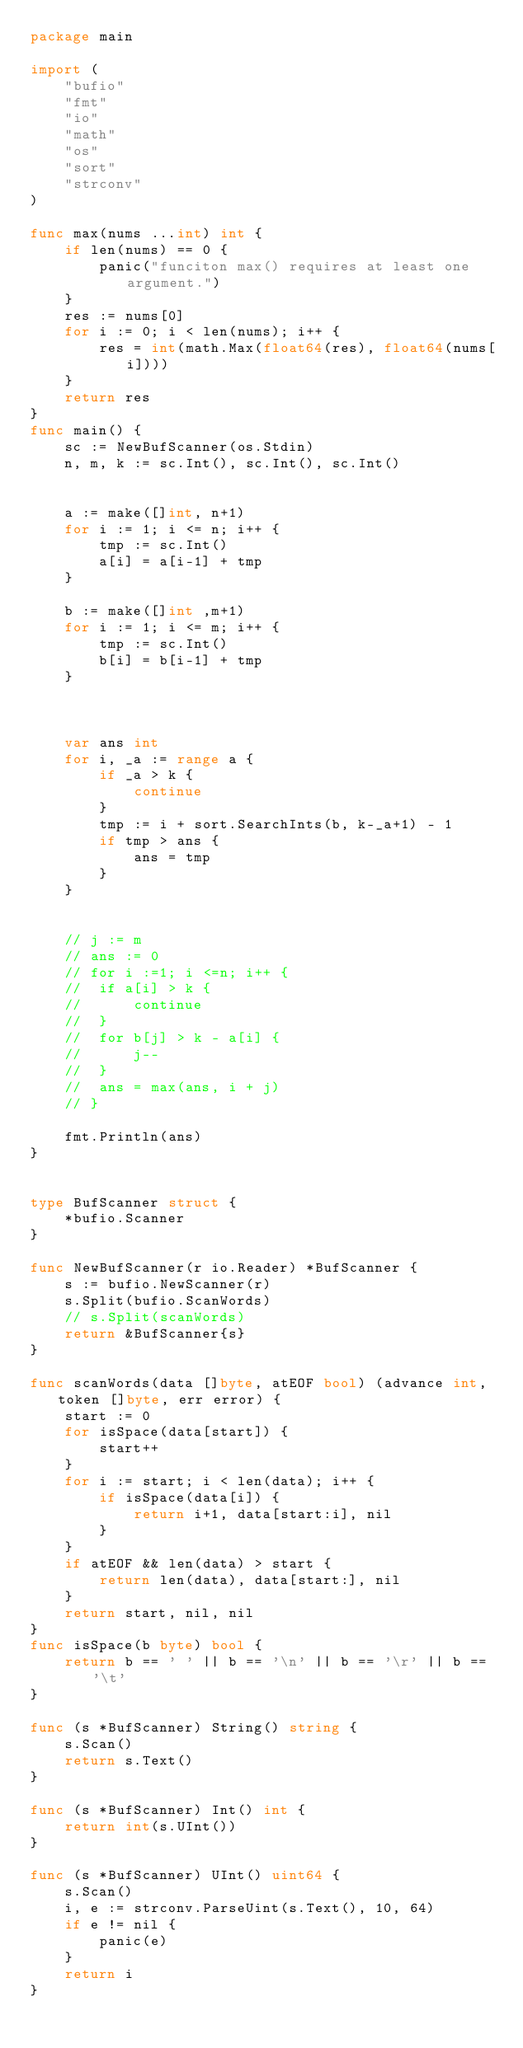Convert code to text. <code><loc_0><loc_0><loc_500><loc_500><_Go_>package main

import (
	"bufio"
	"fmt"
	"io"
	"math"
	"os"
	"sort"
	"strconv"
)

func max(nums ...int) int {
	if len(nums) == 0 {
		panic("funciton max() requires at least one argument.")
	}
	res := nums[0]
	for i := 0; i < len(nums); i++ {
		res = int(math.Max(float64(res), float64(nums[i])))
	}
	return res
}
func main() {
	sc := NewBufScanner(os.Stdin)
	n, m, k := sc.Int(), sc.Int(), sc.Int()


	a := make([]int, n+1)
	for i := 1; i <= n; i++ {
		tmp := sc.Int()
		a[i] = a[i-1] + tmp
	}

	b := make([]int ,m+1)
	for i := 1; i <= m; i++ {
		tmp := sc.Int()
		b[i] = b[i-1] + tmp
	}



	var ans int
	for i, _a := range a {
		if _a > k {
			continue
		}
		tmp := i + sort.SearchInts(b, k-_a+1) - 1
		if tmp > ans {
			ans = tmp
		}
	}

	
	// j := m
	// ans := 0
	// for i :=1; i <=n; i++ {
	// 	if a[i] > k {
	// 		continue
	// 	}
	// 	for b[j] > k - a[i] {
	// 		j--
	// 	}
	// 	ans = max(ans, i + j)
	// }

	fmt.Println(ans)
}


type BufScanner struct {
	*bufio.Scanner
}

func NewBufScanner(r io.Reader) *BufScanner {
	s := bufio.NewScanner(r)
	s.Split(bufio.ScanWords)
	// s.Split(scanWords)
	return &BufScanner{s}
}

func scanWords(data []byte, atEOF bool) (advance int, token []byte, err error) {
	start := 0
	for isSpace(data[start]) {
		start++
	}
	for i := start; i < len(data); i++ {
		if isSpace(data[i]) {
			return i+1, data[start:i], nil
		}
	}
	if atEOF && len(data) > start {
		return len(data), data[start:], nil
	}
	return start, nil, nil
}
func isSpace(b byte) bool {
	return b == ' ' || b == '\n' || b == '\r' || b == '\t'
}

func (s *BufScanner) String() string {
	s.Scan()
	return s.Text()
}

func (s *BufScanner) Int() int {
	return int(s.UInt())
}

func (s *BufScanner) UInt() uint64 {
	s.Scan()
	i, e := strconv.ParseUint(s.Text(), 10, 64)
	if e != nil {
		panic(e)
	}
	return i
}
</code> 